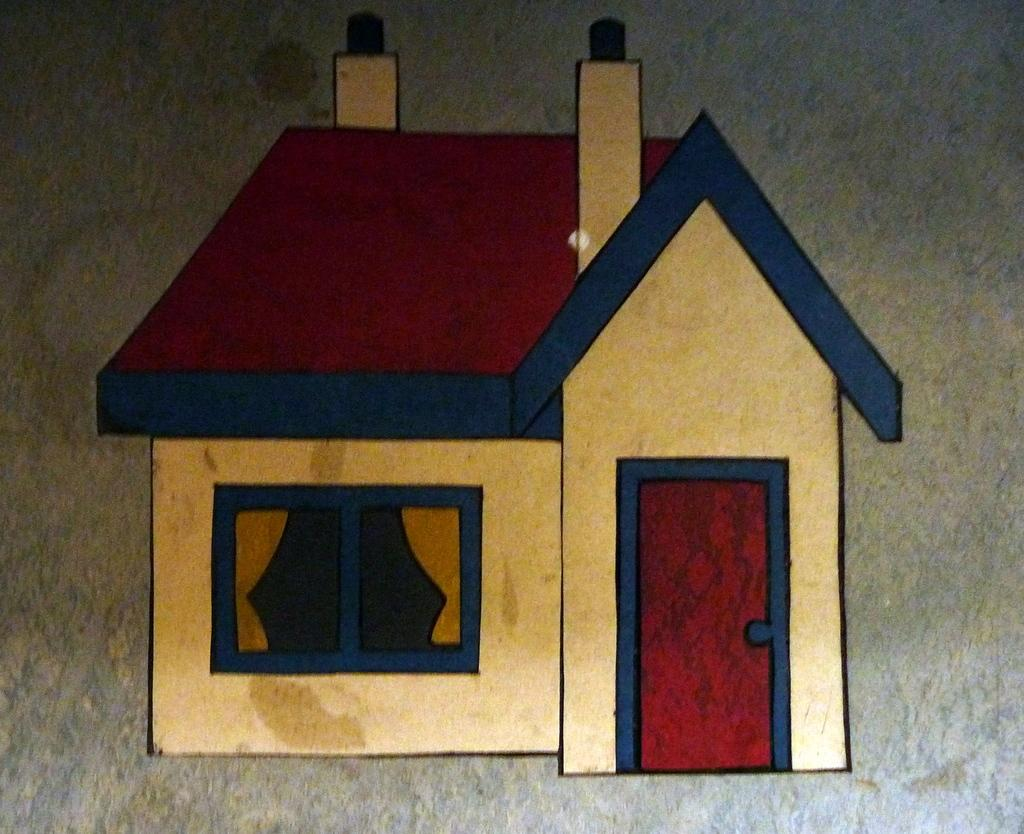What is the main subject in the center of the image? There is an object in the center of the image. What is depicted on the object? The object has a picture of a house. What specific features can be seen in the picture of the house? The picture of the house includes chimneys, a window, curtains, and a door. How much does the toothpaste cost in the image? There is no toothpaste present in the image. What type of brake is visible in the image? There is no brake present in the image. 